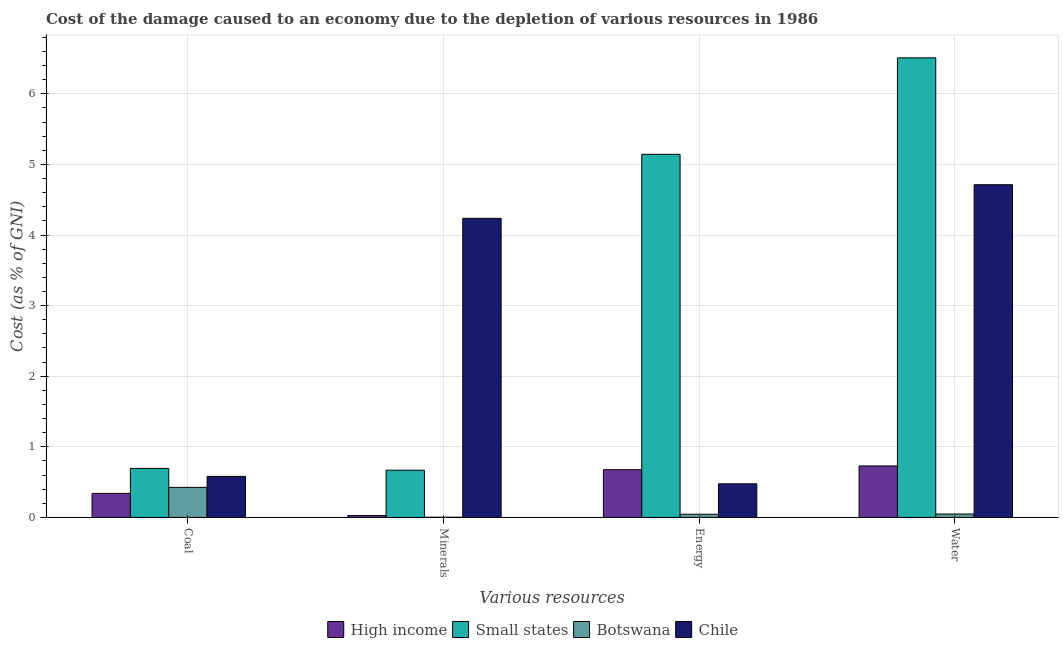How many different coloured bars are there?
Keep it short and to the point. 4. Are the number of bars per tick equal to the number of legend labels?
Provide a succinct answer. Yes. Are the number of bars on each tick of the X-axis equal?
Your response must be concise. Yes. How many bars are there on the 3rd tick from the left?
Keep it short and to the point. 4. What is the label of the 2nd group of bars from the left?
Provide a short and direct response. Minerals. What is the cost of damage due to depletion of energy in High income?
Your response must be concise. 0.68. Across all countries, what is the maximum cost of damage due to depletion of coal?
Make the answer very short. 0.69. Across all countries, what is the minimum cost of damage due to depletion of water?
Give a very brief answer. 0.05. In which country was the cost of damage due to depletion of coal maximum?
Offer a very short reply. Small states. In which country was the cost of damage due to depletion of water minimum?
Your response must be concise. Botswana. What is the total cost of damage due to depletion of coal in the graph?
Ensure brevity in your answer.  2.04. What is the difference between the cost of damage due to depletion of energy in High income and that in Chile?
Offer a terse response. 0.2. What is the difference between the cost of damage due to depletion of water in Small states and the cost of damage due to depletion of minerals in Chile?
Provide a short and direct response. 2.27. What is the average cost of damage due to depletion of minerals per country?
Offer a very short reply. 1.23. What is the difference between the cost of damage due to depletion of minerals and cost of damage due to depletion of water in High income?
Your response must be concise. -0.7. In how many countries, is the cost of damage due to depletion of energy greater than 6 %?
Give a very brief answer. 0. What is the ratio of the cost of damage due to depletion of water in Chile to that in Botswana?
Make the answer very short. 97.18. Is the cost of damage due to depletion of energy in Chile less than that in High income?
Keep it short and to the point. Yes. Is the difference between the cost of damage due to depletion of water in Botswana and Chile greater than the difference between the cost of damage due to depletion of energy in Botswana and Chile?
Your answer should be very brief. No. What is the difference between the highest and the second highest cost of damage due to depletion of energy?
Ensure brevity in your answer.  4.47. What is the difference between the highest and the lowest cost of damage due to depletion of energy?
Your answer should be compact. 5.1. Is it the case that in every country, the sum of the cost of damage due to depletion of water and cost of damage due to depletion of energy is greater than the sum of cost of damage due to depletion of coal and cost of damage due to depletion of minerals?
Your answer should be compact. No. How many countries are there in the graph?
Your response must be concise. 4. Are the values on the major ticks of Y-axis written in scientific E-notation?
Keep it short and to the point. No. Does the graph contain grids?
Give a very brief answer. Yes. Where does the legend appear in the graph?
Ensure brevity in your answer.  Bottom center. How many legend labels are there?
Your answer should be very brief. 4. How are the legend labels stacked?
Your answer should be compact. Horizontal. What is the title of the graph?
Provide a succinct answer. Cost of the damage caused to an economy due to the depletion of various resources in 1986 . Does "Congo (Democratic)" appear as one of the legend labels in the graph?
Make the answer very short. No. What is the label or title of the X-axis?
Give a very brief answer. Various resources. What is the label or title of the Y-axis?
Keep it short and to the point. Cost (as % of GNI). What is the Cost (as % of GNI) of High income in Coal?
Make the answer very short. 0.34. What is the Cost (as % of GNI) of Small states in Coal?
Offer a terse response. 0.69. What is the Cost (as % of GNI) of Botswana in Coal?
Give a very brief answer. 0.43. What is the Cost (as % of GNI) of Chile in Coal?
Keep it short and to the point. 0.58. What is the Cost (as % of GNI) in High income in Minerals?
Provide a succinct answer. 0.03. What is the Cost (as % of GNI) in Small states in Minerals?
Offer a very short reply. 0.67. What is the Cost (as % of GNI) of Botswana in Minerals?
Make the answer very short. 0. What is the Cost (as % of GNI) of Chile in Minerals?
Your answer should be compact. 4.24. What is the Cost (as % of GNI) of High income in Energy?
Offer a terse response. 0.68. What is the Cost (as % of GNI) of Small states in Energy?
Provide a succinct answer. 5.14. What is the Cost (as % of GNI) in Botswana in Energy?
Offer a very short reply. 0.05. What is the Cost (as % of GNI) of Chile in Energy?
Offer a very short reply. 0.48. What is the Cost (as % of GNI) in High income in Water?
Your answer should be very brief. 0.73. What is the Cost (as % of GNI) in Small states in Water?
Keep it short and to the point. 6.51. What is the Cost (as % of GNI) in Botswana in Water?
Ensure brevity in your answer.  0.05. What is the Cost (as % of GNI) in Chile in Water?
Make the answer very short. 4.71. Across all Various resources, what is the maximum Cost (as % of GNI) in High income?
Keep it short and to the point. 0.73. Across all Various resources, what is the maximum Cost (as % of GNI) in Small states?
Make the answer very short. 6.51. Across all Various resources, what is the maximum Cost (as % of GNI) of Botswana?
Give a very brief answer. 0.43. Across all Various resources, what is the maximum Cost (as % of GNI) of Chile?
Keep it short and to the point. 4.71. Across all Various resources, what is the minimum Cost (as % of GNI) of High income?
Provide a succinct answer. 0.03. Across all Various resources, what is the minimum Cost (as % of GNI) in Small states?
Make the answer very short. 0.67. Across all Various resources, what is the minimum Cost (as % of GNI) of Botswana?
Offer a very short reply. 0. Across all Various resources, what is the minimum Cost (as % of GNI) in Chile?
Your answer should be compact. 0.48. What is the total Cost (as % of GNI) of High income in the graph?
Make the answer very short. 1.77. What is the total Cost (as % of GNI) of Small states in the graph?
Your answer should be very brief. 13.02. What is the total Cost (as % of GNI) in Botswana in the graph?
Your response must be concise. 0.52. What is the total Cost (as % of GNI) of Chile in the graph?
Ensure brevity in your answer.  10.01. What is the difference between the Cost (as % of GNI) of High income in Coal and that in Minerals?
Provide a succinct answer. 0.31. What is the difference between the Cost (as % of GNI) of Small states in Coal and that in Minerals?
Provide a succinct answer. 0.03. What is the difference between the Cost (as % of GNI) in Botswana in Coal and that in Minerals?
Give a very brief answer. 0.42. What is the difference between the Cost (as % of GNI) of Chile in Coal and that in Minerals?
Make the answer very short. -3.65. What is the difference between the Cost (as % of GNI) of High income in Coal and that in Energy?
Ensure brevity in your answer.  -0.34. What is the difference between the Cost (as % of GNI) in Small states in Coal and that in Energy?
Ensure brevity in your answer.  -4.45. What is the difference between the Cost (as % of GNI) of Botswana in Coal and that in Energy?
Your answer should be very brief. 0.38. What is the difference between the Cost (as % of GNI) in Chile in Coal and that in Energy?
Provide a succinct answer. 0.11. What is the difference between the Cost (as % of GNI) in High income in Coal and that in Water?
Offer a terse response. -0.39. What is the difference between the Cost (as % of GNI) in Small states in Coal and that in Water?
Keep it short and to the point. -5.81. What is the difference between the Cost (as % of GNI) in Botswana in Coal and that in Water?
Ensure brevity in your answer.  0.38. What is the difference between the Cost (as % of GNI) in Chile in Coal and that in Water?
Give a very brief answer. -4.13. What is the difference between the Cost (as % of GNI) of High income in Minerals and that in Energy?
Provide a short and direct response. -0.65. What is the difference between the Cost (as % of GNI) in Small states in Minerals and that in Energy?
Ensure brevity in your answer.  -4.47. What is the difference between the Cost (as % of GNI) in Botswana in Minerals and that in Energy?
Keep it short and to the point. -0.04. What is the difference between the Cost (as % of GNI) in Chile in Minerals and that in Energy?
Give a very brief answer. 3.76. What is the difference between the Cost (as % of GNI) in High income in Minerals and that in Water?
Offer a terse response. -0.7. What is the difference between the Cost (as % of GNI) in Small states in Minerals and that in Water?
Make the answer very short. -5.84. What is the difference between the Cost (as % of GNI) of Botswana in Minerals and that in Water?
Offer a very short reply. -0.05. What is the difference between the Cost (as % of GNI) of Chile in Minerals and that in Water?
Provide a succinct answer. -0.48. What is the difference between the Cost (as % of GNI) in High income in Energy and that in Water?
Give a very brief answer. -0.05. What is the difference between the Cost (as % of GNI) of Small states in Energy and that in Water?
Your answer should be compact. -1.37. What is the difference between the Cost (as % of GNI) in Botswana in Energy and that in Water?
Give a very brief answer. -0. What is the difference between the Cost (as % of GNI) of Chile in Energy and that in Water?
Your answer should be very brief. -4.24. What is the difference between the Cost (as % of GNI) of High income in Coal and the Cost (as % of GNI) of Small states in Minerals?
Make the answer very short. -0.33. What is the difference between the Cost (as % of GNI) in High income in Coal and the Cost (as % of GNI) in Botswana in Minerals?
Ensure brevity in your answer.  0.34. What is the difference between the Cost (as % of GNI) of High income in Coal and the Cost (as % of GNI) of Chile in Minerals?
Give a very brief answer. -3.9. What is the difference between the Cost (as % of GNI) in Small states in Coal and the Cost (as % of GNI) in Botswana in Minerals?
Ensure brevity in your answer.  0.69. What is the difference between the Cost (as % of GNI) of Small states in Coal and the Cost (as % of GNI) of Chile in Minerals?
Provide a short and direct response. -3.54. What is the difference between the Cost (as % of GNI) of Botswana in Coal and the Cost (as % of GNI) of Chile in Minerals?
Provide a short and direct response. -3.81. What is the difference between the Cost (as % of GNI) in High income in Coal and the Cost (as % of GNI) in Small states in Energy?
Your answer should be very brief. -4.8. What is the difference between the Cost (as % of GNI) in High income in Coal and the Cost (as % of GNI) in Botswana in Energy?
Your response must be concise. 0.29. What is the difference between the Cost (as % of GNI) of High income in Coal and the Cost (as % of GNI) of Chile in Energy?
Offer a very short reply. -0.14. What is the difference between the Cost (as % of GNI) in Small states in Coal and the Cost (as % of GNI) in Botswana in Energy?
Provide a short and direct response. 0.65. What is the difference between the Cost (as % of GNI) in Small states in Coal and the Cost (as % of GNI) in Chile in Energy?
Provide a succinct answer. 0.22. What is the difference between the Cost (as % of GNI) of Botswana in Coal and the Cost (as % of GNI) of Chile in Energy?
Your response must be concise. -0.05. What is the difference between the Cost (as % of GNI) of High income in Coal and the Cost (as % of GNI) of Small states in Water?
Your response must be concise. -6.17. What is the difference between the Cost (as % of GNI) of High income in Coal and the Cost (as % of GNI) of Botswana in Water?
Ensure brevity in your answer.  0.29. What is the difference between the Cost (as % of GNI) of High income in Coal and the Cost (as % of GNI) of Chile in Water?
Give a very brief answer. -4.37. What is the difference between the Cost (as % of GNI) of Small states in Coal and the Cost (as % of GNI) of Botswana in Water?
Make the answer very short. 0.65. What is the difference between the Cost (as % of GNI) in Small states in Coal and the Cost (as % of GNI) in Chile in Water?
Your answer should be compact. -4.02. What is the difference between the Cost (as % of GNI) of Botswana in Coal and the Cost (as % of GNI) of Chile in Water?
Provide a short and direct response. -4.29. What is the difference between the Cost (as % of GNI) of High income in Minerals and the Cost (as % of GNI) of Small states in Energy?
Offer a terse response. -5.12. What is the difference between the Cost (as % of GNI) in High income in Minerals and the Cost (as % of GNI) in Botswana in Energy?
Make the answer very short. -0.02. What is the difference between the Cost (as % of GNI) in High income in Minerals and the Cost (as % of GNI) in Chile in Energy?
Keep it short and to the point. -0.45. What is the difference between the Cost (as % of GNI) in Small states in Minerals and the Cost (as % of GNI) in Botswana in Energy?
Offer a very short reply. 0.62. What is the difference between the Cost (as % of GNI) in Small states in Minerals and the Cost (as % of GNI) in Chile in Energy?
Offer a very short reply. 0.19. What is the difference between the Cost (as % of GNI) of Botswana in Minerals and the Cost (as % of GNI) of Chile in Energy?
Provide a short and direct response. -0.47. What is the difference between the Cost (as % of GNI) of High income in Minerals and the Cost (as % of GNI) of Small states in Water?
Your answer should be compact. -6.48. What is the difference between the Cost (as % of GNI) of High income in Minerals and the Cost (as % of GNI) of Botswana in Water?
Ensure brevity in your answer.  -0.02. What is the difference between the Cost (as % of GNI) in High income in Minerals and the Cost (as % of GNI) in Chile in Water?
Give a very brief answer. -4.69. What is the difference between the Cost (as % of GNI) of Small states in Minerals and the Cost (as % of GNI) of Botswana in Water?
Make the answer very short. 0.62. What is the difference between the Cost (as % of GNI) of Small states in Minerals and the Cost (as % of GNI) of Chile in Water?
Ensure brevity in your answer.  -4.04. What is the difference between the Cost (as % of GNI) in Botswana in Minerals and the Cost (as % of GNI) in Chile in Water?
Your response must be concise. -4.71. What is the difference between the Cost (as % of GNI) of High income in Energy and the Cost (as % of GNI) of Small states in Water?
Provide a short and direct response. -5.83. What is the difference between the Cost (as % of GNI) in High income in Energy and the Cost (as % of GNI) in Botswana in Water?
Your response must be concise. 0.63. What is the difference between the Cost (as % of GNI) of High income in Energy and the Cost (as % of GNI) of Chile in Water?
Make the answer very short. -4.04. What is the difference between the Cost (as % of GNI) in Small states in Energy and the Cost (as % of GNI) in Botswana in Water?
Keep it short and to the point. 5.09. What is the difference between the Cost (as % of GNI) in Small states in Energy and the Cost (as % of GNI) in Chile in Water?
Keep it short and to the point. 0.43. What is the difference between the Cost (as % of GNI) in Botswana in Energy and the Cost (as % of GNI) in Chile in Water?
Keep it short and to the point. -4.67. What is the average Cost (as % of GNI) in High income per Various resources?
Your answer should be very brief. 0.44. What is the average Cost (as % of GNI) of Small states per Various resources?
Provide a short and direct response. 3.25. What is the average Cost (as % of GNI) of Botswana per Various resources?
Provide a succinct answer. 0.13. What is the average Cost (as % of GNI) of Chile per Various resources?
Provide a succinct answer. 2.5. What is the difference between the Cost (as % of GNI) of High income and Cost (as % of GNI) of Small states in Coal?
Provide a short and direct response. -0.35. What is the difference between the Cost (as % of GNI) in High income and Cost (as % of GNI) in Botswana in Coal?
Your answer should be compact. -0.09. What is the difference between the Cost (as % of GNI) in High income and Cost (as % of GNI) in Chile in Coal?
Offer a very short reply. -0.24. What is the difference between the Cost (as % of GNI) of Small states and Cost (as % of GNI) of Botswana in Coal?
Your answer should be compact. 0.27. What is the difference between the Cost (as % of GNI) of Small states and Cost (as % of GNI) of Chile in Coal?
Your answer should be compact. 0.11. What is the difference between the Cost (as % of GNI) in Botswana and Cost (as % of GNI) in Chile in Coal?
Make the answer very short. -0.16. What is the difference between the Cost (as % of GNI) of High income and Cost (as % of GNI) of Small states in Minerals?
Provide a short and direct response. -0.64. What is the difference between the Cost (as % of GNI) of High income and Cost (as % of GNI) of Botswana in Minerals?
Offer a terse response. 0.02. What is the difference between the Cost (as % of GNI) of High income and Cost (as % of GNI) of Chile in Minerals?
Offer a very short reply. -4.21. What is the difference between the Cost (as % of GNI) in Small states and Cost (as % of GNI) in Botswana in Minerals?
Provide a succinct answer. 0.67. What is the difference between the Cost (as % of GNI) in Small states and Cost (as % of GNI) in Chile in Minerals?
Provide a succinct answer. -3.57. What is the difference between the Cost (as % of GNI) in Botswana and Cost (as % of GNI) in Chile in Minerals?
Give a very brief answer. -4.23. What is the difference between the Cost (as % of GNI) in High income and Cost (as % of GNI) in Small states in Energy?
Make the answer very short. -4.47. What is the difference between the Cost (as % of GNI) of High income and Cost (as % of GNI) of Botswana in Energy?
Your answer should be very brief. 0.63. What is the difference between the Cost (as % of GNI) in High income and Cost (as % of GNI) in Chile in Energy?
Make the answer very short. 0.2. What is the difference between the Cost (as % of GNI) in Small states and Cost (as % of GNI) in Botswana in Energy?
Offer a very short reply. 5.1. What is the difference between the Cost (as % of GNI) in Small states and Cost (as % of GNI) in Chile in Energy?
Provide a short and direct response. 4.67. What is the difference between the Cost (as % of GNI) of Botswana and Cost (as % of GNI) of Chile in Energy?
Your answer should be compact. -0.43. What is the difference between the Cost (as % of GNI) of High income and Cost (as % of GNI) of Small states in Water?
Ensure brevity in your answer.  -5.78. What is the difference between the Cost (as % of GNI) in High income and Cost (as % of GNI) in Botswana in Water?
Offer a very short reply. 0.68. What is the difference between the Cost (as % of GNI) in High income and Cost (as % of GNI) in Chile in Water?
Your answer should be compact. -3.98. What is the difference between the Cost (as % of GNI) of Small states and Cost (as % of GNI) of Botswana in Water?
Make the answer very short. 6.46. What is the difference between the Cost (as % of GNI) in Small states and Cost (as % of GNI) in Chile in Water?
Keep it short and to the point. 1.8. What is the difference between the Cost (as % of GNI) of Botswana and Cost (as % of GNI) of Chile in Water?
Offer a terse response. -4.66. What is the ratio of the Cost (as % of GNI) in High income in Coal to that in Minerals?
Your answer should be very brief. 12.7. What is the ratio of the Cost (as % of GNI) of Small states in Coal to that in Minerals?
Your answer should be compact. 1.04. What is the ratio of the Cost (as % of GNI) of Botswana in Coal to that in Minerals?
Make the answer very short. 137.96. What is the ratio of the Cost (as % of GNI) in Chile in Coal to that in Minerals?
Provide a short and direct response. 0.14. What is the ratio of the Cost (as % of GNI) in High income in Coal to that in Energy?
Your response must be concise. 0.5. What is the ratio of the Cost (as % of GNI) in Small states in Coal to that in Energy?
Ensure brevity in your answer.  0.14. What is the ratio of the Cost (as % of GNI) of Botswana in Coal to that in Energy?
Give a very brief answer. 9.38. What is the ratio of the Cost (as % of GNI) of Chile in Coal to that in Energy?
Offer a terse response. 1.22. What is the ratio of the Cost (as % of GNI) of High income in Coal to that in Water?
Offer a very short reply. 0.47. What is the ratio of the Cost (as % of GNI) of Small states in Coal to that in Water?
Ensure brevity in your answer.  0.11. What is the ratio of the Cost (as % of GNI) in Botswana in Coal to that in Water?
Ensure brevity in your answer.  8.78. What is the ratio of the Cost (as % of GNI) in Chile in Coal to that in Water?
Offer a terse response. 0.12. What is the ratio of the Cost (as % of GNI) in High income in Minerals to that in Energy?
Make the answer very short. 0.04. What is the ratio of the Cost (as % of GNI) of Small states in Minerals to that in Energy?
Give a very brief answer. 0.13. What is the ratio of the Cost (as % of GNI) in Botswana in Minerals to that in Energy?
Keep it short and to the point. 0.07. What is the ratio of the Cost (as % of GNI) of Chile in Minerals to that in Energy?
Offer a very short reply. 8.9. What is the ratio of the Cost (as % of GNI) in High income in Minerals to that in Water?
Give a very brief answer. 0.04. What is the ratio of the Cost (as % of GNI) of Small states in Minerals to that in Water?
Offer a very short reply. 0.1. What is the ratio of the Cost (as % of GNI) of Botswana in Minerals to that in Water?
Provide a short and direct response. 0.06. What is the ratio of the Cost (as % of GNI) of Chile in Minerals to that in Water?
Make the answer very short. 0.9. What is the ratio of the Cost (as % of GNI) in High income in Energy to that in Water?
Your answer should be compact. 0.93. What is the ratio of the Cost (as % of GNI) of Small states in Energy to that in Water?
Offer a very short reply. 0.79. What is the ratio of the Cost (as % of GNI) in Botswana in Energy to that in Water?
Make the answer very short. 0.94. What is the ratio of the Cost (as % of GNI) of Chile in Energy to that in Water?
Your answer should be very brief. 0.1. What is the difference between the highest and the second highest Cost (as % of GNI) in High income?
Your answer should be very brief. 0.05. What is the difference between the highest and the second highest Cost (as % of GNI) of Small states?
Your answer should be compact. 1.37. What is the difference between the highest and the second highest Cost (as % of GNI) in Botswana?
Provide a succinct answer. 0.38. What is the difference between the highest and the second highest Cost (as % of GNI) in Chile?
Offer a very short reply. 0.48. What is the difference between the highest and the lowest Cost (as % of GNI) in High income?
Your answer should be compact. 0.7. What is the difference between the highest and the lowest Cost (as % of GNI) of Small states?
Your answer should be very brief. 5.84. What is the difference between the highest and the lowest Cost (as % of GNI) in Botswana?
Give a very brief answer. 0.42. What is the difference between the highest and the lowest Cost (as % of GNI) of Chile?
Ensure brevity in your answer.  4.24. 